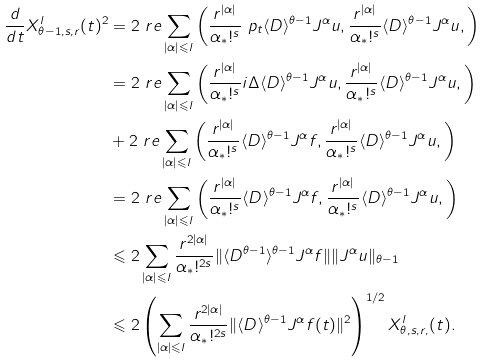Convert formula to latex. <formula><loc_0><loc_0><loc_500><loc_500>\frac { d } { d t } X _ { \theta - 1 , s , r } ^ { l } ( t ) ^ { 2 } & = 2 \ r e \sum _ { | \alpha | \leqslant { l } } \left ( \frac { r ^ { | \alpha | } } { \alpha _ { \ast } ! ^ { s } } \ p _ { t } \langle { D } \rangle ^ { \theta - 1 } J ^ { \alpha } { u } , \frac { r ^ { | \alpha | } } { \alpha _ { \ast } ! ^ { s } } \langle { D } \rangle ^ { \theta - 1 } J ^ { \alpha } { u } , \right ) \\ & = 2 \ r e \sum _ { | \alpha | \leqslant { l } } \left ( \frac { r ^ { | \alpha | } } { \alpha _ { \ast } ! ^ { s } } i \Delta \langle { D } \rangle ^ { \theta - 1 } J ^ { \alpha } { u } , \frac { r ^ { | \alpha | } } { \alpha _ { \ast } ! ^ { s } } \langle { D } \rangle ^ { \theta - 1 } J ^ { \alpha } { u } , \right ) \\ & + 2 \ r e \sum _ { | \alpha | \leqslant { l } } \left ( \frac { r ^ { | \alpha | } } { \alpha _ { \ast } ! ^ { s } } \langle { D } \rangle ^ { \theta - 1 } J ^ { \alpha } { f } , \frac { r ^ { | \alpha | } } { \alpha _ { \ast } ! ^ { s } } \langle { D } \rangle ^ { \theta - 1 } J ^ { \alpha } { u } , \right ) \\ & = 2 \ r e \sum _ { | \alpha | \leqslant { l } } \left ( \frac { r ^ { | \alpha | } } { \alpha _ { \ast } ! ^ { s } } \langle { D } \rangle ^ { \theta - 1 } J ^ { \alpha } { f } , \frac { r ^ { | \alpha | } } { \alpha _ { \ast } ! ^ { s } } \langle { D } \rangle ^ { \theta - 1 } J ^ { \alpha } { u } , \right ) \\ & \leqslant 2 \sum _ { | \alpha | \leqslant { l } } \frac { r ^ { 2 | \alpha | } } { \alpha _ { \ast } ! ^ { 2 s } } \| \langle { D } ^ { \theta - 1 } \rangle ^ { \theta - 1 } J ^ { \alpha } { f } \| \| { J ^ { \alpha } } u \| _ { \theta - 1 } \\ & \leqslant 2 \left ( \sum _ { | \alpha | \leqslant { l } } \frac { r ^ { 2 | \alpha | } } { \alpha _ { \ast } ! ^ { 2 s } } \| \langle { D } \rangle ^ { \theta - 1 } J ^ { \alpha } { f ( t ) } \| ^ { 2 } \right ) ^ { 1 / 2 } X _ { \theta , s , r , } ^ { l } ( t ) .</formula> 